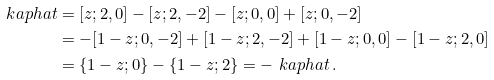<formula> <loc_0><loc_0><loc_500><loc_500>\ k a p h a t & = [ z ; 2 , 0 ] - [ z ; 2 , - 2 ] - [ z ; 0 , 0 ] + [ z ; 0 , - 2 ] \\ & = - [ 1 - z ; 0 , - 2 ] + [ 1 - z ; 2 , - 2 ] + [ 1 - z ; 0 , 0 ] - [ 1 - z ; 2 , 0 ] \\ & = \{ 1 - z ; 0 \} - \{ 1 - z ; 2 \} = - \ k a p h a t \, .</formula> 